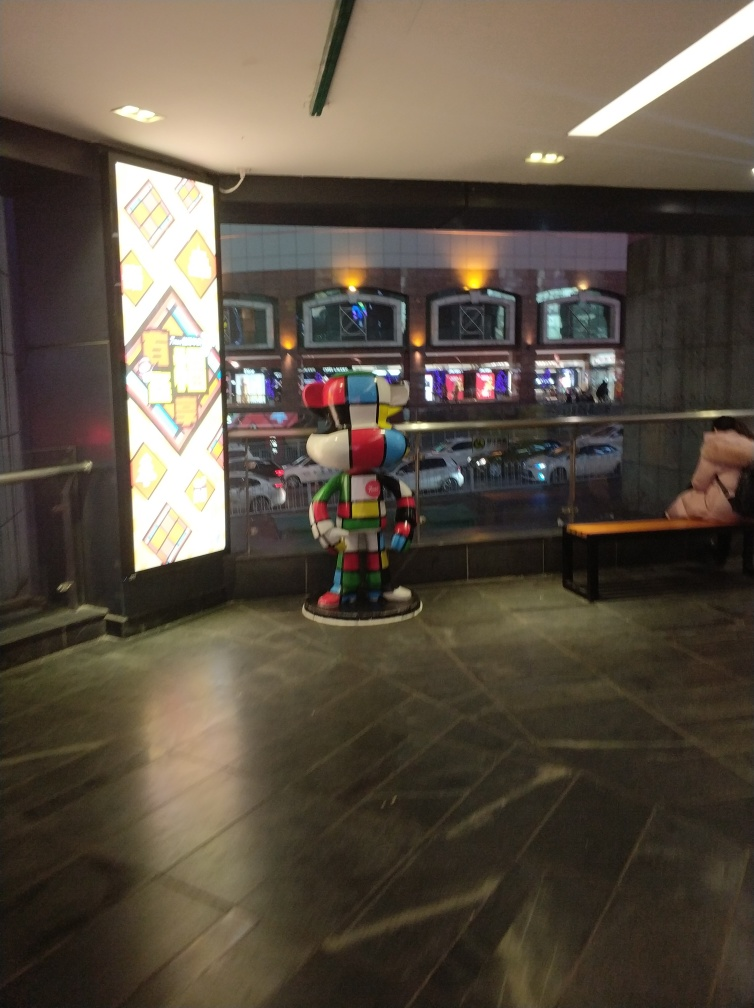What is the style of the artwork displayed on the light column? The artwork on the light column features a geometric pattern with a variety of shapes and vibrant colors. It has a modern, abstract aesthetic. 